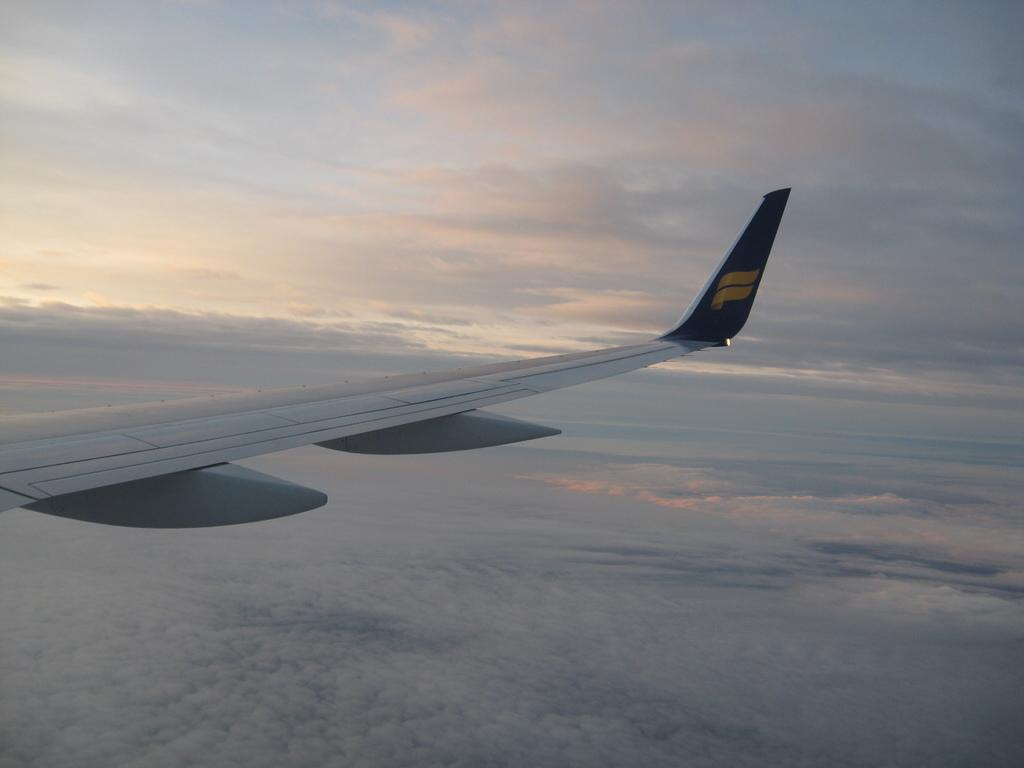What is the main subject of the image? The main subject of the image is an airplane wing. What can be seen in the background of the image? There are clouds visible in the image. What is the income of the airplane manager in the image? There is no information about an airplane manager or their income in the image. 